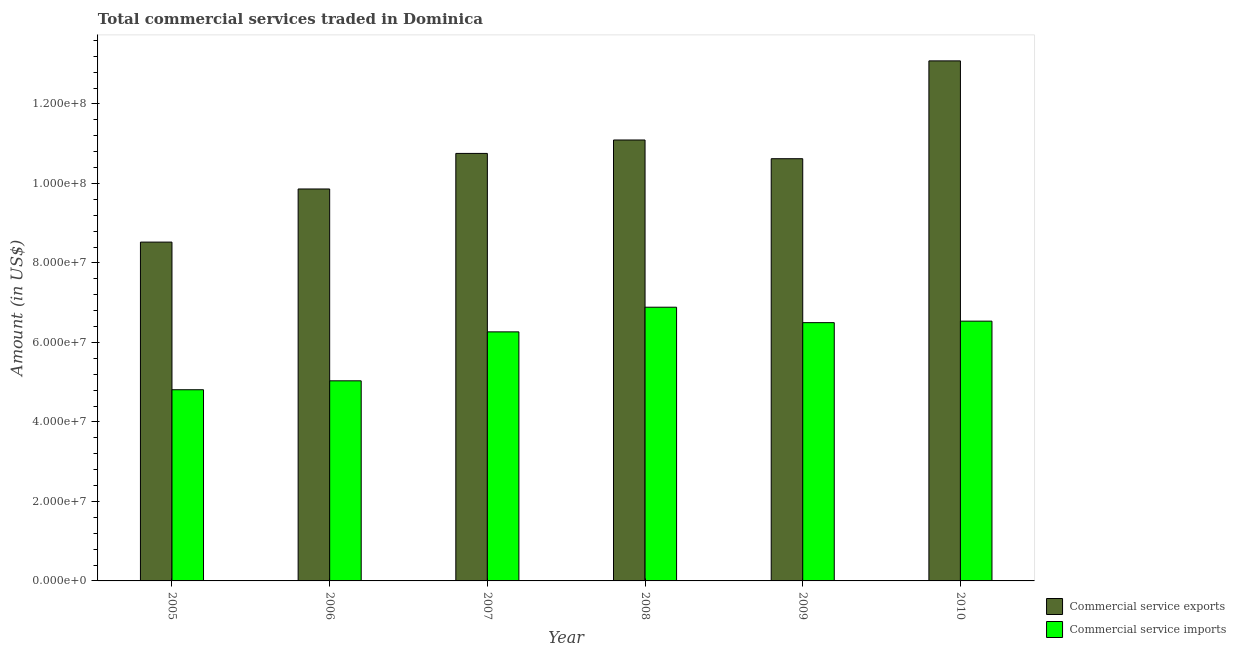How many different coloured bars are there?
Give a very brief answer. 2. How many groups of bars are there?
Give a very brief answer. 6. Are the number of bars on each tick of the X-axis equal?
Make the answer very short. Yes. How many bars are there on the 6th tick from the left?
Provide a short and direct response. 2. How many bars are there on the 5th tick from the right?
Ensure brevity in your answer.  2. What is the amount of commercial service imports in 2008?
Provide a short and direct response. 6.89e+07. Across all years, what is the maximum amount of commercial service exports?
Make the answer very short. 1.31e+08. Across all years, what is the minimum amount of commercial service imports?
Offer a very short reply. 4.81e+07. In which year was the amount of commercial service imports minimum?
Make the answer very short. 2005. What is the total amount of commercial service exports in the graph?
Your answer should be compact. 6.39e+08. What is the difference between the amount of commercial service exports in 2005 and that in 2010?
Offer a very short reply. -4.56e+07. What is the difference between the amount of commercial service imports in 2008 and the amount of commercial service exports in 2007?
Your response must be concise. 6.21e+06. What is the average amount of commercial service imports per year?
Your answer should be compact. 6.00e+07. In the year 2005, what is the difference between the amount of commercial service exports and amount of commercial service imports?
Your answer should be very brief. 0. What is the ratio of the amount of commercial service exports in 2005 to that in 2006?
Provide a short and direct response. 0.86. Is the difference between the amount of commercial service exports in 2005 and 2006 greater than the difference between the amount of commercial service imports in 2005 and 2006?
Your answer should be very brief. No. What is the difference between the highest and the second highest amount of commercial service imports?
Make the answer very short. 3.51e+06. What is the difference between the highest and the lowest amount of commercial service exports?
Keep it short and to the point. 4.56e+07. In how many years, is the amount of commercial service imports greater than the average amount of commercial service imports taken over all years?
Offer a terse response. 4. What does the 2nd bar from the left in 2006 represents?
Ensure brevity in your answer.  Commercial service imports. What does the 2nd bar from the right in 2005 represents?
Make the answer very short. Commercial service exports. Are all the bars in the graph horizontal?
Your answer should be very brief. No. What is the difference between two consecutive major ticks on the Y-axis?
Ensure brevity in your answer.  2.00e+07. Does the graph contain any zero values?
Your answer should be compact. No. Does the graph contain grids?
Offer a very short reply. No. Where does the legend appear in the graph?
Make the answer very short. Bottom right. How many legend labels are there?
Your answer should be very brief. 2. What is the title of the graph?
Provide a succinct answer. Total commercial services traded in Dominica. What is the label or title of the X-axis?
Make the answer very short. Year. What is the label or title of the Y-axis?
Provide a short and direct response. Amount (in US$). What is the Amount (in US$) in Commercial service exports in 2005?
Make the answer very short. 8.52e+07. What is the Amount (in US$) of Commercial service imports in 2005?
Give a very brief answer. 4.81e+07. What is the Amount (in US$) in Commercial service exports in 2006?
Offer a very short reply. 9.86e+07. What is the Amount (in US$) in Commercial service imports in 2006?
Your answer should be compact. 5.03e+07. What is the Amount (in US$) of Commercial service exports in 2007?
Your response must be concise. 1.08e+08. What is the Amount (in US$) in Commercial service imports in 2007?
Provide a succinct answer. 6.27e+07. What is the Amount (in US$) of Commercial service exports in 2008?
Your answer should be very brief. 1.11e+08. What is the Amount (in US$) in Commercial service imports in 2008?
Keep it short and to the point. 6.89e+07. What is the Amount (in US$) in Commercial service exports in 2009?
Your answer should be compact. 1.06e+08. What is the Amount (in US$) in Commercial service imports in 2009?
Make the answer very short. 6.50e+07. What is the Amount (in US$) in Commercial service exports in 2010?
Keep it short and to the point. 1.31e+08. What is the Amount (in US$) of Commercial service imports in 2010?
Give a very brief answer. 6.53e+07. Across all years, what is the maximum Amount (in US$) of Commercial service exports?
Provide a succinct answer. 1.31e+08. Across all years, what is the maximum Amount (in US$) of Commercial service imports?
Offer a very short reply. 6.89e+07. Across all years, what is the minimum Amount (in US$) of Commercial service exports?
Keep it short and to the point. 8.52e+07. Across all years, what is the minimum Amount (in US$) of Commercial service imports?
Provide a succinct answer. 4.81e+07. What is the total Amount (in US$) in Commercial service exports in the graph?
Ensure brevity in your answer.  6.39e+08. What is the total Amount (in US$) of Commercial service imports in the graph?
Provide a short and direct response. 3.60e+08. What is the difference between the Amount (in US$) in Commercial service exports in 2005 and that in 2006?
Provide a succinct answer. -1.34e+07. What is the difference between the Amount (in US$) in Commercial service imports in 2005 and that in 2006?
Offer a very short reply. -2.24e+06. What is the difference between the Amount (in US$) in Commercial service exports in 2005 and that in 2007?
Your answer should be very brief. -2.23e+07. What is the difference between the Amount (in US$) of Commercial service imports in 2005 and that in 2007?
Your answer should be very brief. -1.46e+07. What is the difference between the Amount (in US$) in Commercial service exports in 2005 and that in 2008?
Provide a succinct answer. -2.57e+07. What is the difference between the Amount (in US$) of Commercial service imports in 2005 and that in 2008?
Offer a very short reply. -2.08e+07. What is the difference between the Amount (in US$) of Commercial service exports in 2005 and that in 2009?
Your answer should be very brief. -2.10e+07. What is the difference between the Amount (in US$) in Commercial service imports in 2005 and that in 2009?
Provide a succinct answer. -1.69e+07. What is the difference between the Amount (in US$) of Commercial service exports in 2005 and that in 2010?
Ensure brevity in your answer.  -4.56e+07. What is the difference between the Amount (in US$) of Commercial service imports in 2005 and that in 2010?
Ensure brevity in your answer.  -1.73e+07. What is the difference between the Amount (in US$) in Commercial service exports in 2006 and that in 2007?
Offer a very short reply. -8.95e+06. What is the difference between the Amount (in US$) of Commercial service imports in 2006 and that in 2007?
Offer a very short reply. -1.23e+07. What is the difference between the Amount (in US$) in Commercial service exports in 2006 and that in 2008?
Your response must be concise. -1.23e+07. What is the difference between the Amount (in US$) of Commercial service imports in 2006 and that in 2008?
Your answer should be compact. -1.85e+07. What is the difference between the Amount (in US$) in Commercial service exports in 2006 and that in 2009?
Your answer should be compact. -7.62e+06. What is the difference between the Amount (in US$) of Commercial service imports in 2006 and that in 2009?
Your response must be concise. -1.46e+07. What is the difference between the Amount (in US$) of Commercial service exports in 2006 and that in 2010?
Offer a terse response. -3.22e+07. What is the difference between the Amount (in US$) of Commercial service imports in 2006 and that in 2010?
Provide a succinct answer. -1.50e+07. What is the difference between the Amount (in US$) in Commercial service exports in 2007 and that in 2008?
Your answer should be compact. -3.38e+06. What is the difference between the Amount (in US$) in Commercial service imports in 2007 and that in 2008?
Your answer should be compact. -6.21e+06. What is the difference between the Amount (in US$) of Commercial service exports in 2007 and that in 2009?
Your answer should be compact. 1.33e+06. What is the difference between the Amount (in US$) of Commercial service imports in 2007 and that in 2009?
Ensure brevity in your answer.  -2.32e+06. What is the difference between the Amount (in US$) in Commercial service exports in 2007 and that in 2010?
Your answer should be very brief. -2.33e+07. What is the difference between the Amount (in US$) in Commercial service imports in 2007 and that in 2010?
Your answer should be compact. -2.70e+06. What is the difference between the Amount (in US$) of Commercial service exports in 2008 and that in 2009?
Make the answer very short. 4.71e+06. What is the difference between the Amount (in US$) in Commercial service imports in 2008 and that in 2009?
Provide a succinct answer. 3.88e+06. What is the difference between the Amount (in US$) of Commercial service exports in 2008 and that in 2010?
Keep it short and to the point. -1.99e+07. What is the difference between the Amount (in US$) in Commercial service imports in 2008 and that in 2010?
Make the answer very short. 3.51e+06. What is the difference between the Amount (in US$) of Commercial service exports in 2009 and that in 2010?
Your answer should be very brief. -2.46e+07. What is the difference between the Amount (in US$) in Commercial service imports in 2009 and that in 2010?
Offer a very short reply. -3.77e+05. What is the difference between the Amount (in US$) in Commercial service exports in 2005 and the Amount (in US$) in Commercial service imports in 2006?
Provide a succinct answer. 3.49e+07. What is the difference between the Amount (in US$) in Commercial service exports in 2005 and the Amount (in US$) in Commercial service imports in 2007?
Offer a terse response. 2.26e+07. What is the difference between the Amount (in US$) in Commercial service exports in 2005 and the Amount (in US$) in Commercial service imports in 2008?
Ensure brevity in your answer.  1.64e+07. What is the difference between the Amount (in US$) in Commercial service exports in 2005 and the Amount (in US$) in Commercial service imports in 2009?
Offer a terse response. 2.03e+07. What is the difference between the Amount (in US$) of Commercial service exports in 2005 and the Amount (in US$) of Commercial service imports in 2010?
Offer a very short reply. 1.99e+07. What is the difference between the Amount (in US$) of Commercial service exports in 2006 and the Amount (in US$) of Commercial service imports in 2007?
Offer a terse response. 3.59e+07. What is the difference between the Amount (in US$) of Commercial service exports in 2006 and the Amount (in US$) of Commercial service imports in 2008?
Give a very brief answer. 2.97e+07. What is the difference between the Amount (in US$) of Commercial service exports in 2006 and the Amount (in US$) of Commercial service imports in 2009?
Your answer should be compact. 3.36e+07. What is the difference between the Amount (in US$) in Commercial service exports in 2006 and the Amount (in US$) in Commercial service imports in 2010?
Ensure brevity in your answer.  3.32e+07. What is the difference between the Amount (in US$) in Commercial service exports in 2007 and the Amount (in US$) in Commercial service imports in 2008?
Provide a short and direct response. 3.87e+07. What is the difference between the Amount (in US$) in Commercial service exports in 2007 and the Amount (in US$) in Commercial service imports in 2009?
Ensure brevity in your answer.  4.26e+07. What is the difference between the Amount (in US$) of Commercial service exports in 2007 and the Amount (in US$) of Commercial service imports in 2010?
Offer a terse response. 4.22e+07. What is the difference between the Amount (in US$) of Commercial service exports in 2008 and the Amount (in US$) of Commercial service imports in 2009?
Keep it short and to the point. 4.59e+07. What is the difference between the Amount (in US$) of Commercial service exports in 2008 and the Amount (in US$) of Commercial service imports in 2010?
Your response must be concise. 4.56e+07. What is the difference between the Amount (in US$) in Commercial service exports in 2009 and the Amount (in US$) in Commercial service imports in 2010?
Your answer should be very brief. 4.09e+07. What is the average Amount (in US$) of Commercial service exports per year?
Ensure brevity in your answer.  1.07e+08. What is the average Amount (in US$) in Commercial service imports per year?
Make the answer very short. 6.00e+07. In the year 2005, what is the difference between the Amount (in US$) of Commercial service exports and Amount (in US$) of Commercial service imports?
Your response must be concise. 3.71e+07. In the year 2006, what is the difference between the Amount (in US$) in Commercial service exports and Amount (in US$) in Commercial service imports?
Your answer should be very brief. 4.83e+07. In the year 2007, what is the difference between the Amount (in US$) of Commercial service exports and Amount (in US$) of Commercial service imports?
Your answer should be very brief. 4.49e+07. In the year 2008, what is the difference between the Amount (in US$) in Commercial service exports and Amount (in US$) in Commercial service imports?
Your answer should be compact. 4.21e+07. In the year 2009, what is the difference between the Amount (in US$) in Commercial service exports and Amount (in US$) in Commercial service imports?
Offer a very short reply. 4.12e+07. In the year 2010, what is the difference between the Amount (in US$) of Commercial service exports and Amount (in US$) of Commercial service imports?
Make the answer very short. 6.55e+07. What is the ratio of the Amount (in US$) in Commercial service exports in 2005 to that in 2006?
Offer a terse response. 0.86. What is the ratio of the Amount (in US$) of Commercial service imports in 2005 to that in 2006?
Keep it short and to the point. 0.96. What is the ratio of the Amount (in US$) in Commercial service exports in 2005 to that in 2007?
Offer a terse response. 0.79. What is the ratio of the Amount (in US$) of Commercial service imports in 2005 to that in 2007?
Your answer should be very brief. 0.77. What is the ratio of the Amount (in US$) of Commercial service exports in 2005 to that in 2008?
Offer a terse response. 0.77. What is the ratio of the Amount (in US$) of Commercial service imports in 2005 to that in 2008?
Your response must be concise. 0.7. What is the ratio of the Amount (in US$) in Commercial service exports in 2005 to that in 2009?
Give a very brief answer. 0.8. What is the ratio of the Amount (in US$) of Commercial service imports in 2005 to that in 2009?
Offer a very short reply. 0.74. What is the ratio of the Amount (in US$) in Commercial service exports in 2005 to that in 2010?
Provide a short and direct response. 0.65. What is the ratio of the Amount (in US$) in Commercial service imports in 2005 to that in 2010?
Ensure brevity in your answer.  0.74. What is the ratio of the Amount (in US$) in Commercial service exports in 2006 to that in 2007?
Your answer should be very brief. 0.92. What is the ratio of the Amount (in US$) of Commercial service imports in 2006 to that in 2007?
Keep it short and to the point. 0.8. What is the ratio of the Amount (in US$) of Commercial service imports in 2006 to that in 2008?
Your answer should be compact. 0.73. What is the ratio of the Amount (in US$) of Commercial service exports in 2006 to that in 2009?
Keep it short and to the point. 0.93. What is the ratio of the Amount (in US$) of Commercial service imports in 2006 to that in 2009?
Make the answer very short. 0.77. What is the ratio of the Amount (in US$) of Commercial service exports in 2006 to that in 2010?
Your response must be concise. 0.75. What is the ratio of the Amount (in US$) of Commercial service imports in 2006 to that in 2010?
Give a very brief answer. 0.77. What is the ratio of the Amount (in US$) of Commercial service exports in 2007 to that in 2008?
Offer a terse response. 0.97. What is the ratio of the Amount (in US$) in Commercial service imports in 2007 to that in 2008?
Your response must be concise. 0.91. What is the ratio of the Amount (in US$) of Commercial service exports in 2007 to that in 2009?
Offer a very short reply. 1.01. What is the ratio of the Amount (in US$) of Commercial service exports in 2007 to that in 2010?
Ensure brevity in your answer.  0.82. What is the ratio of the Amount (in US$) of Commercial service imports in 2007 to that in 2010?
Your answer should be compact. 0.96. What is the ratio of the Amount (in US$) of Commercial service exports in 2008 to that in 2009?
Your answer should be compact. 1.04. What is the ratio of the Amount (in US$) in Commercial service imports in 2008 to that in 2009?
Provide a succinct answer. 1.06. What is the ratio of the Amount (in US$) in Commercial service exports in 2008 to that in 2010?
Keep it short and to the point. 0.85. What is the ratio of the Amount (in US$) of Commercial service imports in 2008 to that in 2010?
Provide a succinct answer. 1.05. What is the ratio of the Amount (in US$) of Commercial service exports in 2009 to that in 2010?
Offer a terse response. 0.81. What is the difference between the highest and the second highest Amount (in US$) in Commercial service exports?
Your answer should be very brief. 1.99e+07. What is the difference between the highest and the second highest Amount (in US$) of Commercial service imports?
Offer a terse response. 3.51e+06. What is the difference between the highest and the lowest Amount (in US$) of Commercial service exports?
Your answer should be compact. 4.56e+07. What is the difference between the highest and the lowest Amount (in US$) of Commercial service imports?
Keep it short and to the point. 2.08e+07. 